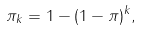<formula> <loc_0><loc_0><loc_500><loc_500>\pi _ { k } = 1 - ( 1 - \pi ) ^ { k } ,</formula> 